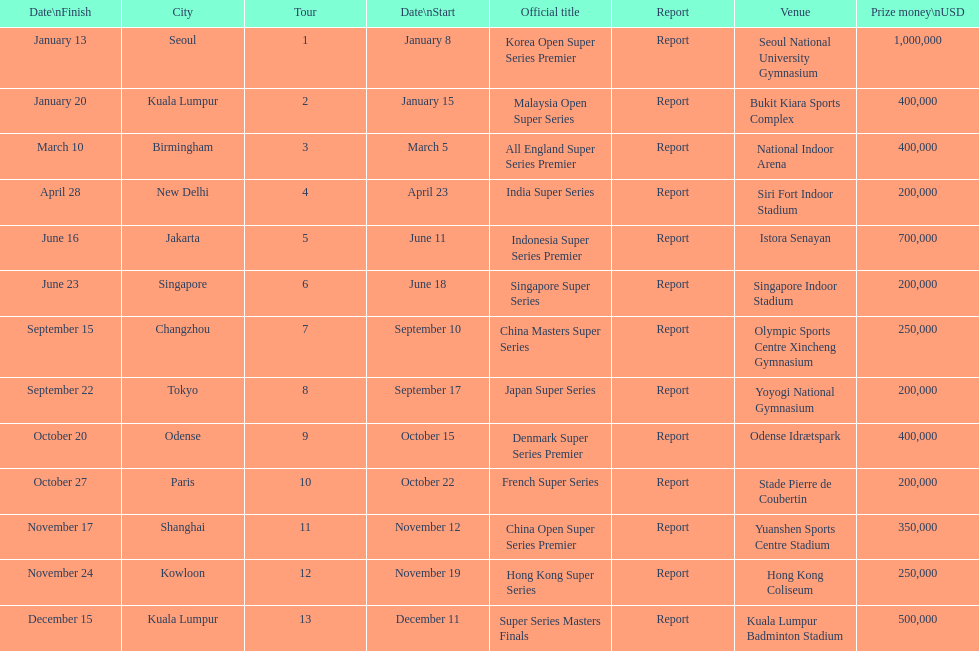What is the total prize payout for all 13 series? 5050000. Parse the table in full. {'header': ['Date\\nFinish', 'City', 'Tour', 'Date\\nStart', 'Official title', 'Report', 'Venue', 'Prize money\\nUSD'], 'rows': [['January 13', 'Seoul', '1', 'January 8', 'Korea Open Super Series Premier', 'Report', 'Seoul National University Gymnasium', '1,000,000'], ['January 20', 'Kuala Lumpur', '2', 'January 15', 'Malaysia Open Super Series', 'Report', 'Bukit Kiara Sports Complex', '400,000'], ['March 10', 'Birmingham', '3', 'March 5', 'All England Super Series Premier', 'Report', 'National Indoor Arena', '400,000'], ['April 28', 'New Delhi', '4', 'April 23', 'India Super Series', 'Report', 'Siri Fort Indoor Stadium', '200,000'], ['June 16', 'Jakarta', '5', 'June 11', 'Indonesia Super Series Premier', 'Report', 'Istora Senayan', '700,000'], ['June 23', 'Singapore', '6', 'June 18', 'Singapore Super Series', 'Report', 'Singapore Indoor Stadium', '200,000'], ['September 15', 'Changzhou', '7', 'September 10', 'China Masters Super Series', 'Report', 'Olympic Sports Centre Xincheng Gymnasium', '250,000'], ['September 22', 'Tokyo', '8', 'September 17', 'Japan Super Series', 'Report', 'Yoyogi National Gymnasium', '200,000'], ['October 20', 'Odense', '9', 'October 15', 'Denmark Super Series Premier', 'Report', 'Odense Idrætspark', '400,000'], ['October 27', 'Paris', '10', 'October 22', 'French Super Series', 'Report', 'Stade Pierre de Coubertin', '200,000'], ['November 17', 'Shanghai', '11', 'November 12', 'China Open Super Series Premier', 'Report', 'Yuanshen Sports Centre Stadium', '350,000'], ['November 24', 'Kowloon', '12', 'November 19', 'Hong Kong Super Series', 'Report', 'Hong Kong Coliseum', '250,000'], ['December 15', 'Kuala Lumpur', '13', 'December 11', 'Super Series Masters Finals', 'Report', 'Kuala Lumpur Badminton Stadium', '500,000']]} 